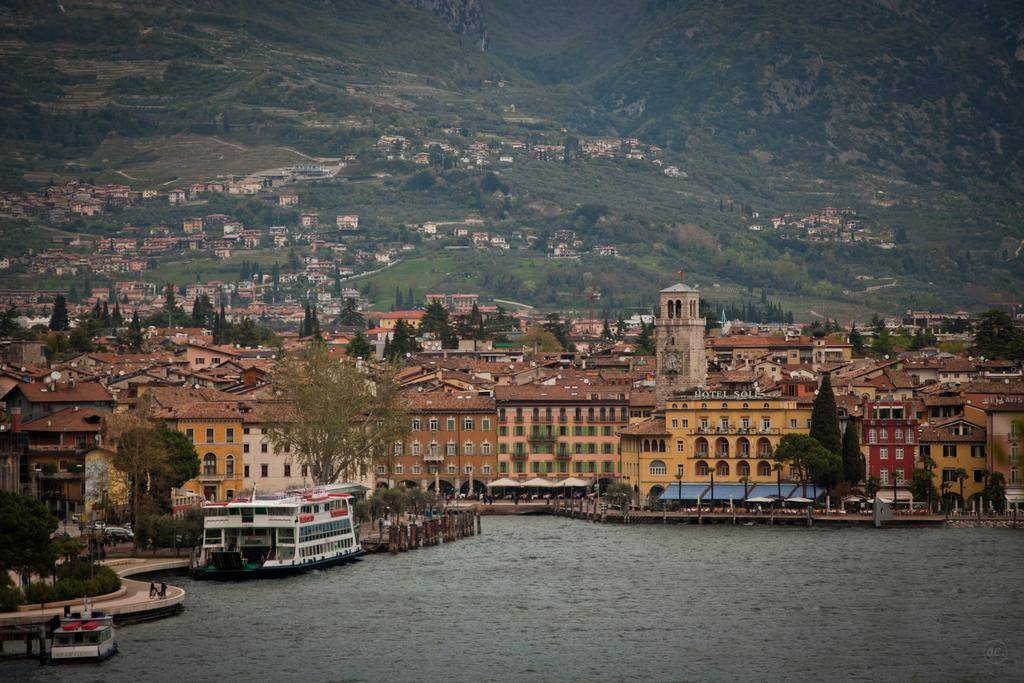What is the primary element in the picture? There is water in the picture. What else can be seen in the water? There are boats in the picture. What structures are visible in the image? There are buildings in the picture. What type of natural vegetation is present in the image? There are trees in the picture. What geographical feature can be seen in the background of the picture? In the background of the picture, there are mountains. What can be found on the mountains in the image? On the mountains, there are houses and trees. What religious beliefs are being practiced in the image? There is no indication of any religious beliefs or practices in the image. What development projects are being carried out in the image? There is no indication of any development projects in the image. 